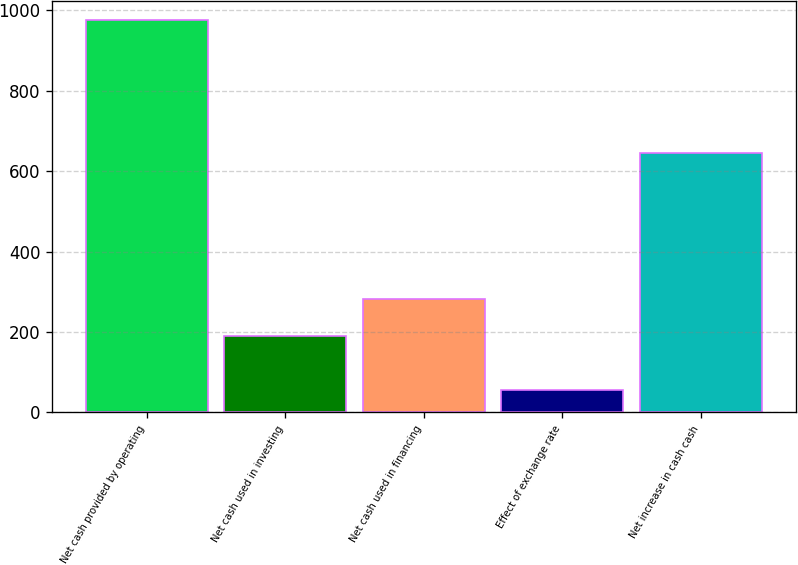Convert chart. <chart><loc_0><loc_0><loc_500><loc_500><bar_chart><fcel>Net cash provided by operating<fcel>Net cash used in investing<fcel>Net cash used in financing<fcel>Effect of exchange rate<fcel>Net increase in cash cash<nl><fcel>975.1<fcel>189.1<fcel>281.09<fcel>55.2<fcel>643.7<nl></chart> 